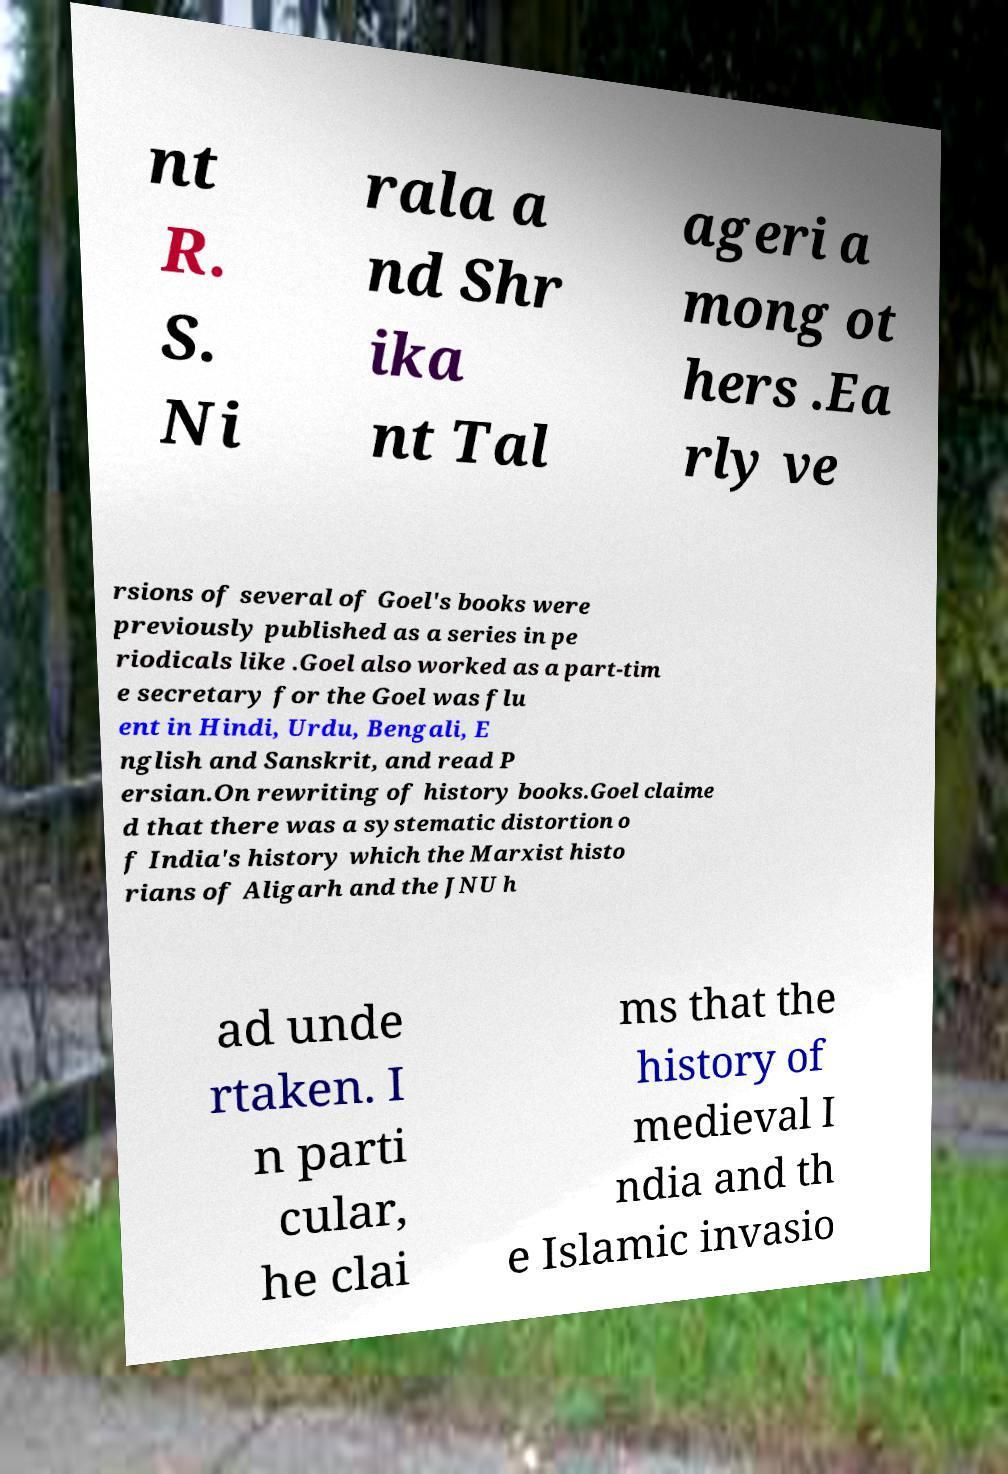Please identify and transcribe the text found in this image. nt R. S. Ni rala a nd Shr ika nt Tal ageri a mong ot hers .Ea rly ve rsions of several of Goel's books were previously published as a series in pe riodicals like .Goel also worked as a part-tim e secretary for the Goel was flu ent in Hindi, Urdu, Bengali, E nglish and Sanskrit, and read P ersian.On rewriting of history books.Goel claime d that there was a systematic distortion o f India's history which the Marxist histo rians of Aligarh and the JNU h ad unde rtaken. I n parti cular, he clai ms that the history of medieval I ndia and th e Islamic invasio 